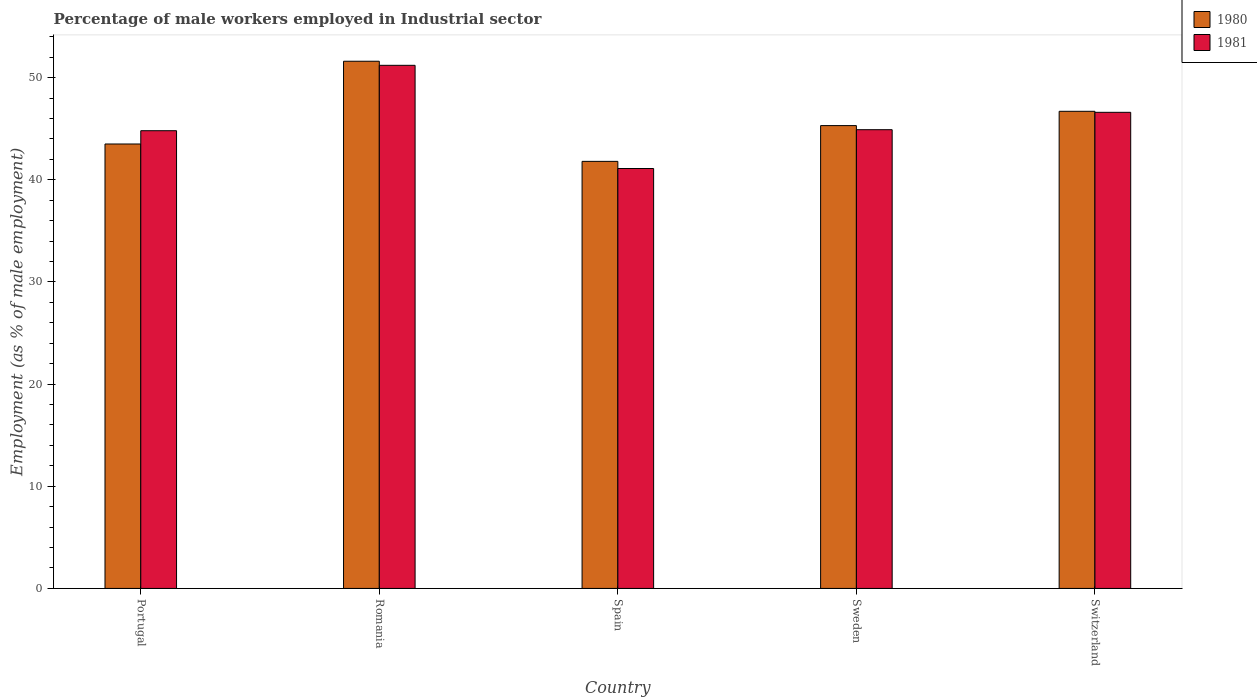How many different coloured bars are there?
Make the answer very short. 2. How many groups of bars are there?
Ensure brevity in your answer.  5. Are the number of bars per tick equal to the number of legend labels?
Offer a very short reply. Yes. Are the number of bars on each tick of the X-axis equal?
Provide a short and direct response. Yes. How many bars are there on the 5th tick from the left?
Your answer should be compact. 2. What is the label of the 5th group of bars from the left?
Make the answer very short. Switzerland. In how many cases, is the number of bars for a given country not equal to the number of legend labels?
Ensure brevity in your answer.  0. What is the percentage of male workers employed in Industrial sector in 1980 in Portugal?
Provide a short and direct response. 43.5. Across all countries, what is the maximum percentage of male workers employed in Industrial sector in 1981?
Make the answer very short. 51.2. Across all countries, what is the minimum percentage of male workers employed in Industrial sector in 1981?
Your answer should be very brief. 41.1. In which country was the percentage of male workers employed in Industrial sector in 1980 maximum?
Offer a terse response. Romania. In which country was the percentage of male workers employed in Industrial sector in 1981 minimum?
Your answer should be compact. Spain. What is the total percentage of male workers employed in Industrial sector in 1981 in the graph?
Provide a succinct answer. 228.6. What is the difference between the percentage of male workers employed in Industrial sector in 1981 in Romania and that in Switzerland?
Provide a short and direct response. 4.6. What is the difference between the percentage of male workers employed in Industrial sector in 1981 in Portugal and the percentage of male workers employed in Industrial sector in 1980 in Spain?
Your answer should be compact. 3. What is the average percentage of male workers employed in Industrial sector in 1980 per country?
Keep it short and to the point. 45.78. What is the difference between the percentage of male workers employed in Industrial sector of/in 1980 and percentage of male workers employed in Industrial sector of/in 1981 in Spain?
Provide a short and direct response. 0.7. What is the ratio of the percentage of male workers employed in Industrial sector in 1981 in Romania to that in Spain?
Offer a very short reply. 1.25. Is the difference between the percentage of male workers employed in Industrial sector in 1980 in Portugal and Switzerland greater than the difference between the percentage of male workers employed in Industrial sector in 1981 in Portugal and Switzerland?
Ensure brevity in your answer.  No. What is the difference between the highest and the second highest percentage of male workers employed in Industrial sector in 1980?
Provide a succinct answer. 6.3. What is the difference between the highest and the lowest percentage of male workers employed in Industrial sector in 1981?
Offer a terse response. 10.1. Is the sum of the percentage of male workers employed in Industrial sector in 1981 in Romania and Sweden greater than the maximum percentage of male workers employed in Industrial sector in 1980 across all countries?
Keep it short and to the point. Yes. What does the 2nd bar from the left in Portugal represents?
Your response must be concise. 1981. What does the 1st bar from the right in Sweden represents?
Provide a succinct answer. 1981. Are all the bars in the graph horizontal?
Offer a terse response. No. How many countries are there in the graph?
Make the answer very short. 5. What is the difference between two consecutive major ticks on the Y-axis?
Offer a very short reply. 10. Where does the legend appear in the graph?
Offer a terse response. Top right. What is the title of the graph?
Make the answer very short. Percentage of male workers employed in Industrial sector. Does "1974" appear as one of the legend labels in the graph?
Your response must be concise. No. What is the label or title of the X-axis?
Your answer should be very brief. Country. What is the label or title of the Y-axis?
Offer a terse response. Employment (as % of male employment). What is the Employment (as % of male employment) in 1980 in Portugal?
Your response must be concise. 43.5. What is the Employment (as % of male employment) of 1981 in Portugal?
Give a very brief answer. 44.8. What is the Employment (as % of male employment) of 1980 in Romania?
Offer a very short reply. 51.6. What is the Employment (as % of male employment) in 1981 in Romania?
Your response must be concise. 51.2. What is the Employment (as % of male employment) in 1980 in Spain?
Provide a short and direct response. 41.8. What is the Employment (as % of male employment) in 1981 in Spain?
Make the answer very short. 41.1. What is the Employment (as % of male employment) of 1980 in Sweden?
Your answer should be very brief. 45.3. What is the Employment (as % of male employment) of 1981 in Sweden?
Make the answer very short. 44.9. What is the Employment (as % of male employment) in 1980 in Switzerland?
Offer a very short reply. 46.7. What is the Employment (as % of male employment) in 1981 in Switzerland?
Offer a very short reply. 46.6. Across all countries, what is the maximum Employment (as % of male employment) of 1980?
Make the answer very short. 51.6. Across all countries, what is the maximum Employment (as % of male employment) in 1981?
Make the answer very short. 51.2. Across all countries, what is the minimum Employment (as % of male employment) in 1980?
Provide a succinct answer. 41.8. Across all countries, what is the minimum Employment (as % of male employment) in 1981?
Your response must be concise. 41.1. What is the total Employment (as % of male employment) in 1980 in the graph?
Make the answer very short. 228.9. What is the total Employment (as % of male employment) in 1981 in the graph?
Your answer should be very brief. 228.6. What is the difference between the Employment (as % of male employment) of 1980 in Portugal and that in Romania?
Make the answer very short. -8.1. What is the difference between the Employment (as % of male employment) in 1980 in Portugal and that in Spain?
Keep it short and to the point. 1.7. What is the difference between the Employment (as % of male employment) in 1981 in Portugal and that in Spain?
Your answer should be very brief. 3.7. What is the difference between the Employment (as % of male employment) of 1980 in Portugal and that in Sweden?
Make the answer very short. -1.8. What is the difference between the Employment (as % of male employment) in 1980 in Portugal and that in Switzerland?
Provide a succinct answer. -3.2. What is the difference between the Employment (as % of male employment) of 1981 in Portugal and that in Switzerland?
Offer a terse response. -1.8. What is the difference between the Employment (as % of male employment) in 1981 in Romania and that in Sweden?
Ensure brevity in your answer.  6.3. What is the difference between the Employment (as % of male employment) in 1980 in Romania and that in Switzerland?
Your answer should be compact. 4.9. What is the difference between the Employment (as % of male employment) of 1981 in Romania and that in Switzerland?
Make the answer very short. 4.6. What is the difference between the Employment (as % of male employment) in 1980 in Portugal and the Employment (as % of male employment) in 1981 in Spain?
Ensure brevity in your answer.  2.4. What is the difference between the Employment (as % of male employment) of 1980 in Portugal and the Employment (as % of male employment) of 1981 in Sweden?
Keep it short and to the point. -1.4. What is the difference between the Employment (as % of male employment) of 1980 in Portugal and the Employment (as % of male employment) of 1981 in Switzerland?
Your answer should be compact. -3.1. What is the difference between the Employment (as % of male employment) in 1980 in Romania and the Employment (as % of male employment) in 1981 in Switzerland?
Provide a succinct answer. 5. What is the difference between the Employment (as % of male employment) of 1980 in Spain and the Employment (as % of male employment) of 1981 in Switzerland?
Provide a succinct answer. -4.8. What is the average Employment (as % of male employment) in 1980 per country?
Make the answer very short. 45.78. What is the average Employment (as % of male employment) of 1981 per country?
Give a very brief answer. 45.72. What is the difference between the Employment (as % of male employment) in 1980 and Employment (as % of male employment) in 1981 in Portugal?
Your answer should be very brief. -1.3. What is the difference between the Employment (as % of male employment) of 1980 and Employment (as % of male employment) of 1981 in Romania?
Your answer should be very brief. 0.4. What is the difference between the Employment (as % of male employment) in 1980 and Employment (as % of male employment) in 1981 in Spain?
Offer a very short reply. 0.7. What is the ratio of the Employment (as % of male employment) of 1980 in Portugal to that in Romania?
Offer a terse response. 0.84. What is the ratio of the Employment (as % of male employment) of 1981 in Portugal to that in Romania?
Your answer should be compact. 0.88. What is the ratio of the Employment (as % of male employment) in 1980 in Portugal to that in Spain?
Your response must be concise. 1.04. What is the ratio of the Employment (as % of male employment) in 1981 in Portugal to that in Spain?
Provide a succinct answer. 1.09. What is the ratio of the Employment (as % of male employment) of 1980 in Portugal to that in Sweden?
Provide a succinct answer. 0.96. What is the ratio of the Employment (as % of male employment) in 1980 in Portugal to that in Switzerland?
Provide a succinct answer. 0.93. What is the ratio of the Employment (as % of male employment) in 1981 in Portugal to that in Switzerland?
Your response must be concise. 0.96. What is the ratio of the Employment (as % of male employment) in 1980 in Romania to that in Spain?
Keep it short and to the point. 1.23. What is the ratio of the Employment (as % of male employment) of 1981 in Romania to that in Spain?
Your answer should be compact. 1.25. What is the ratio of the Employment (as % of male employment) in 1980 in Romania to that in Sweden?
Keep it short and to the point. 1.14. What is the ratio of the Employment (as % of male employment) of 1981 in Romania to that in Sweden?
Your answer should be very brief. 1.14. What is the ratio of the Employment (as % of male employment) of 1980 in Romania to that in Switzerland?
Make the answer very short. 1.1. What is the ratio of the Employment (as % of male employment) in 1981 in Romania to that in Switzerland?
Give a very brief answer. 1.1. What is the ratio of the Employment (as % of male employment) in 1980 in Spain to that in Sweden?
Make the answer very short. 0.92. What is the ratio of the Employment (as % of male employment) of 1981 in Spain to that in Sweden?
Your response must be concise. 0.92. What is the ratio of the Employment (as % of male employment) in 1980 in Spain to that in Switzerland?
Make the answer very short. 0.9. What is the ratio of the Employment (as % of male employment) of 1981 in Spain to that in Switzerland?
Ensure brevity in your answer.  0.88. What is the ratio of the Employment (as % of male employment) of 1980 in Sweden to that in Switzerland?
Your answer should be very brief. 0.97. What is the ratio of the Employment (as % of male employment) in 1981 in Sweden to that in Switzerland?
Provide a succinct answer. 0.96. What is the difference between the highest and the second highest Employment (as % of male employment) of 1980?
Keep it short and to the point. 4.9. What is the difference between the highest and the second highest Employment (as % of male employment) of 1981?
Offer a terse response. 4.6. What is the difference between the highest and the lowest Employment (as % of male employment) of 1980?
Provide a short and direct response. 9.8. 